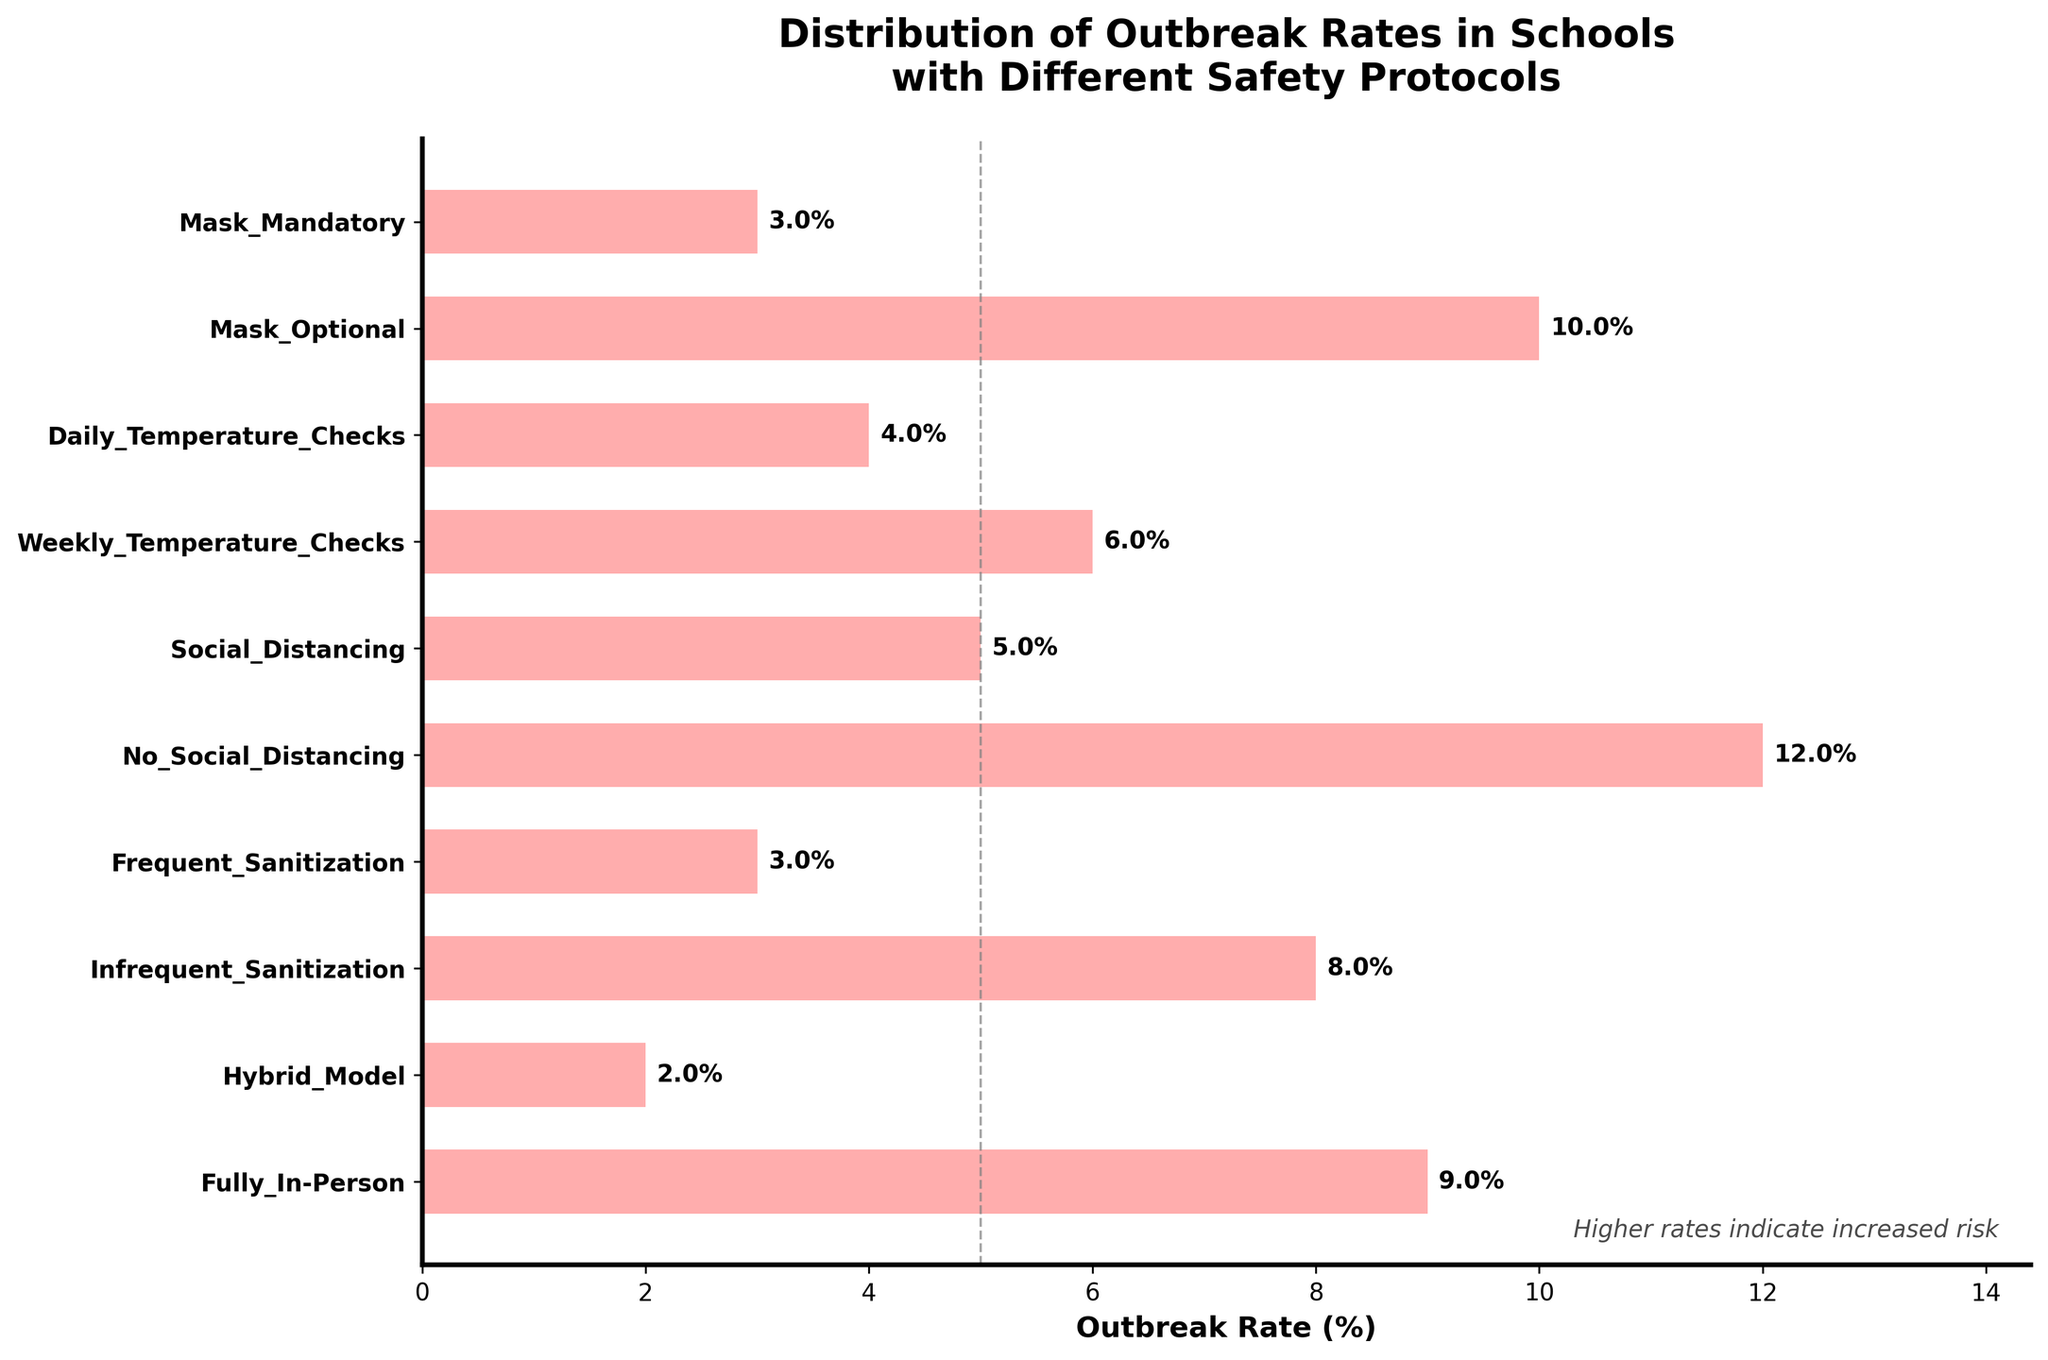Which safety protocol has the highest outbreak rate? By observing the bar lengths in the chart, the longest bar represents the highest outbreak rate, which corresponds to the safety protocol "No_Social_Distancing".
Answer: No_Social_Distancing Which safety protocol has the lowest outbreak rate? By looking at the figure, the shortest bar in the chart corresponds to the safety protocol "Hybrid_Model".
Answer: Hybrid_Model Is the outbreak rate for schools with mandatory masks higher or lower than schools with mandatory daily temperature checks? The bar for "Mask_Mandatory" is at 3%, whereas the bar for "Daily_Temperature_Checks" is at 4%. Therefore, the outbreak rate for schools with mandatory masks is lower.
Answer: Lower What is the difference in outbreak rates between schools with frequent sanitization and infrequent sanitization? The bar for "Frequent_Sanitization" is at 3%, and the bar for "Infrequent_Sanitization" is at 8%. The difference is 8% - 3% = 5%.
Answer: 5% What is the combined outbreak rate for schools that practice social distancing and hybrid models? The bar for "Social_Distancing" is at 5%, and the bar for "Hybrid_Model" is at 2%. Combined, they sum up to 5% + 2% = 7%.
Answer: 7% Is the outbreak rate for fully in-person classes greater than the average outbreak rate of mask mandatory and mask optional protocols? The bar for "Fully_In-Person" is at 9%. The bars for "Mask_Mandatory" and "Mask_Optional" are at 3% and 10%, respectively. The average for mask protocols is (3% + 10%) / 2 = 6.5%. Since 9% is greater than 6.5%, the outbreak rate for fully in-person classes is higher.
Answer: Yes How many protocols have an outbreak rate less than or equal to 4%? The bars for "Mask_Mandatory" (3%), "Daily_Temperature_Checks" (4%), "Frequent_Sanitization" (3%), and "Hybrid_Model" (2%) are all less than or equal to 4%. Thus, there are 4 protocols.
Answer: 4 Which safety protocol has a higher outbreak rate: weekly temperature checks or no social distancing? The bar for "Weekly_Temperature_Checks" is at 6%, whereas the bar for "No_Social_Distancing" is at 12%. Thus, no social distancing has a higher outbreak rate.
Answer: No_Social_Distancing What is the outbreak rate for the protocol that uses daily temperature checks? The bar for "Daily_Temperature_Checks" shows a value of 4%.
Answer: 4% 